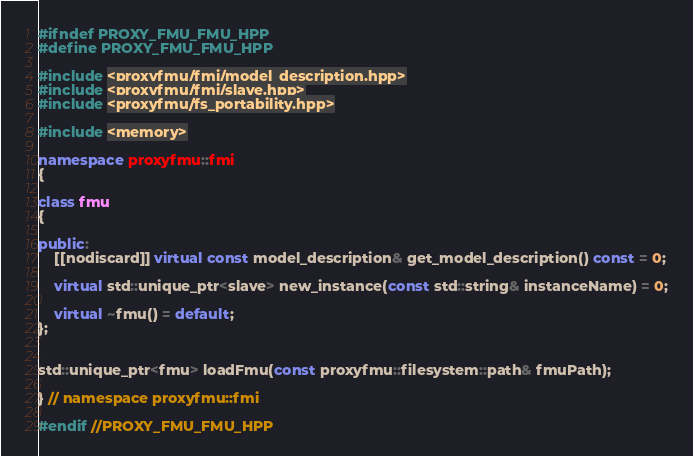<code> <loc_0><loc_0><loc_500><loc_500><_C++_>
#ifndef PROXY_FMU_FMU_HPP
#define PROXY_FMU_FMU_HPP

#include <proxyfmu/fmi/model_description.hpp>
#include <proxyfmu/fmi/slave.hpp>
#include <proxyfmu/fs_portability.hpp>

#include <memory>

namespace proxyfmu::fmi
{

class fmu
{

public:
    [[nodiscard]] virtual const model_description& get_model_description() const = 0;

    virtual std::unique_ptr<slave> new_instance(const std::string& instanceName) = 0;

    virtual ~fmu() = default;
};


std::unique_ptr<fmu> loadFmu(const proxyfmu::filesystem::path& fmuPath);

} // namespace proxyfmu::fmi

#endif //PROXY_FMU_FMU_HPP
</code> 